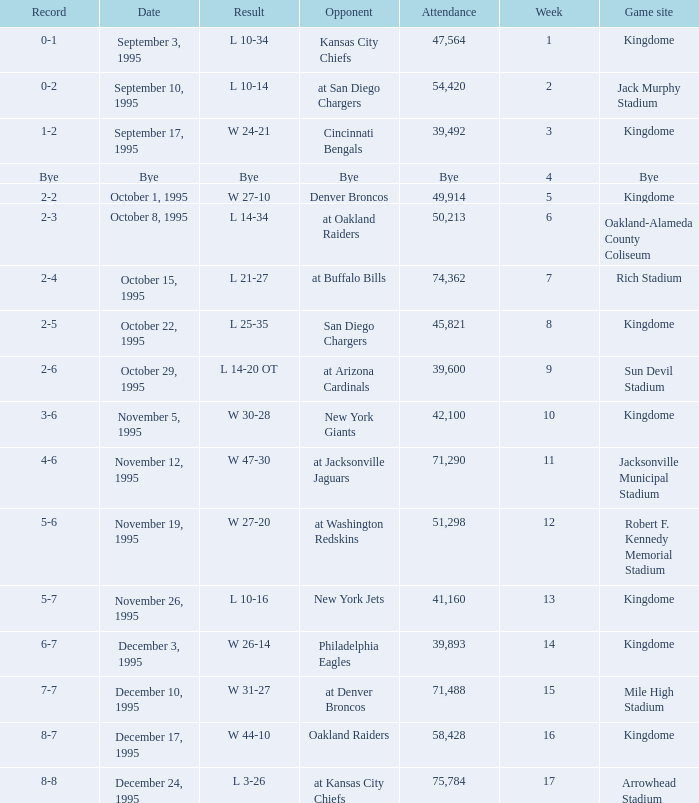Who was the adversary when the seattle seahawks had a 0-1 record? Kansas City Chiefs. 